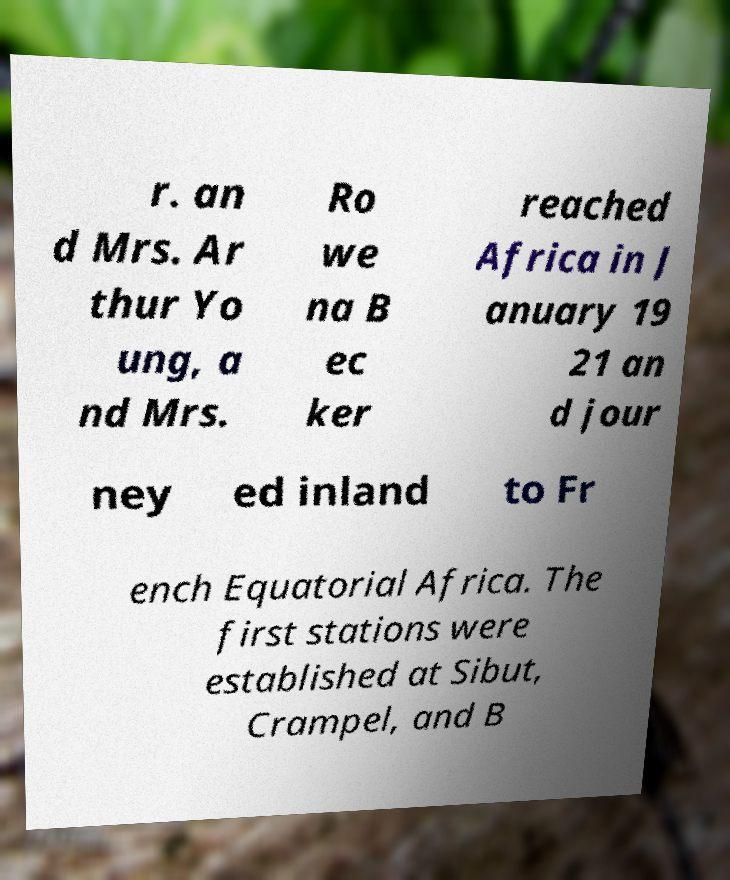I need the written content from this picture converted into text. Can you do that? r. an d Mrs. Ar thur Yo ung, a nd Mrs. Ro we na B ec ker reached Africa in J anuary 19 21 an d jour ney ed inland to Fr ench Equatorial Africa. The first stations were established at Sibut, Crampel, and B 